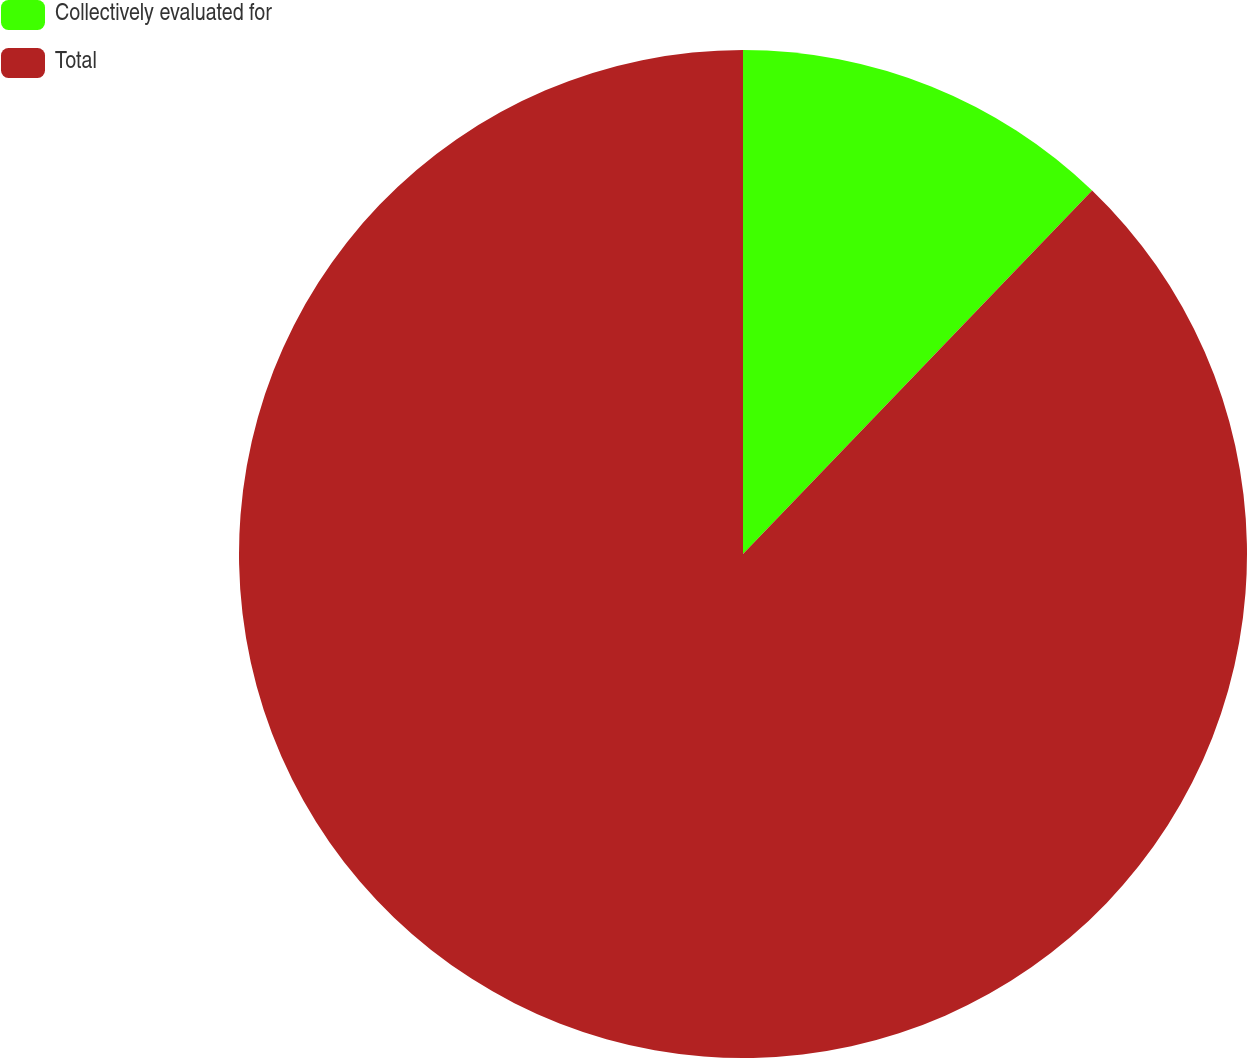<chart> <loc_0><loc_0><loc_500><loc_500><pie_chart><fcel>Collectively evaluated for<fcel>Total<nl><fcel>12.18%<fcel>87.82%<nl></chart> 